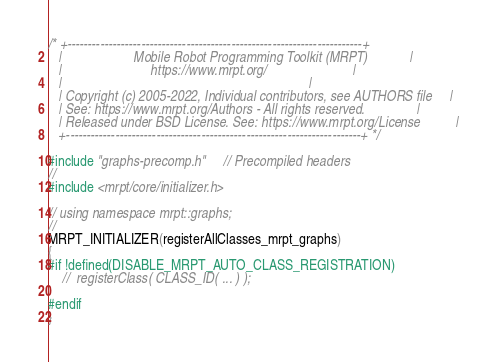<code> <loc_0><loc_0><loc_500><loc_500><_C++_>/* +------------------------------------------------------------------------+
   |                     Mobile Robot Programming Toolkit (MRPT)            |
   |                          https://www.mrpt.org/                         |
   |                                                                        |
   | Copyright (c) 2005-2022, Individual contributors, see AUTHORS file     |
   | See: https://www.mrpt.org/Authors - All rights reserved.               |
   | Released under BSD License. See: https://www.mrpt.org/License          |
   +------------------------------------------------------------------------+ */

#include "graphs-precomp.h"	 // Precompiled headers
//
#include <mrpt/core/initializer.h>

// using namespace mrpt::graphs;
//
MRPT_INITIALIZER(registerAllClasses_mrpt_graphs)
{
#if !defined(DISABLE_MRPT_AUTO_CLASS_REGISTRATION)
	//	registerClass( CLASS_ID( ... ) );

#endif
}
</code> 